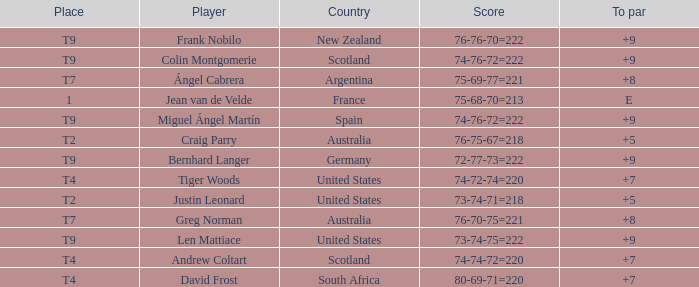When david frost recorded a to par of +7 in a match, what was the end score? 80-69-71=220. 